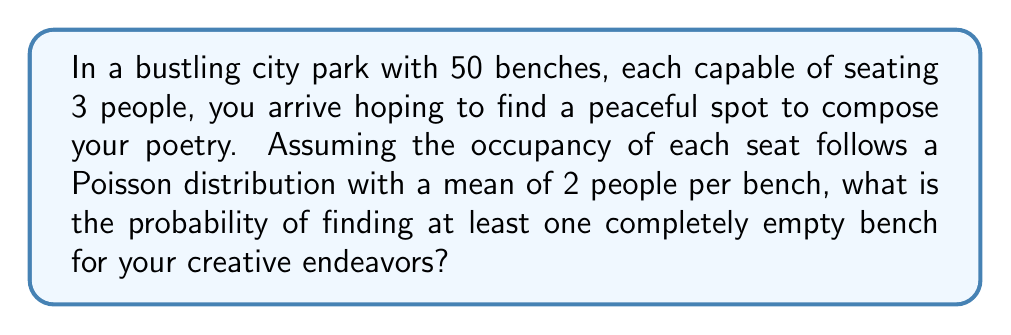Help me with this question. Let's approach this step-by-step:

1) First, we need to find the probability of a single bench being empty. 

2) The occupancy of each seat follows a Poisson distribution with mean $\lambda = 2$ people per bench.

3) The probability of a bench being empty is the probability of 0 people occupying it:

   $P(X = 0) = \frac{e^{-\lambda}\lambda^0}{0!} = e^{-2}$

4) Now, the probability of a bench not being empty is:

   $P(\text{not empty}) = 1 - P(\text{empty}) = 1 - e^{-2}$

5) For all 50 benches to have at least one person, each bench must not be empty. The probability of this is:

   $P(\text{all benches not empty}) = (1 - e^{-2})^{50}$

6) Therefore, the probability of at least one bench being empty is:

   $P(\text{at least one empty}) = 1 - P(\text{all benches not empty})$
   $= 1 - (1 - e^{-2})^{50}$

7) Calculating this:

   $1 - (1 - e^{-2})^{50} \approx 0.9999999999999906$
Answer: $1 - (1 - e^{-2})^{50} \approx 0.9999999999999906$ 